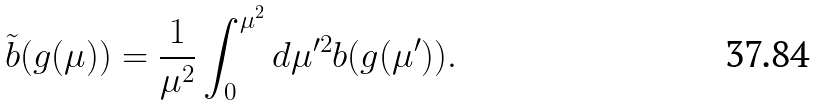Convert formula to latex. <formula><loc_0><loc_0><loc_500><loc_500>\tilde { b } ( g ( \mu ) ) = \frac { 1 } { \mu ^ { 2 } } \int _ { 0 } ^ { \mu ^ { 2 } } d \mu ^ { \prime 2 } b ( g ( \mu ^ { \prime } ) ) .</formula> 